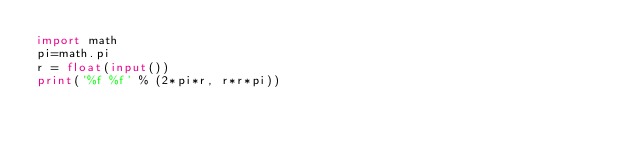<code> <loc_0><loc_0><loc_500><loc_500><_Python_>import math
pi=math.pi
r = float(input())
print('%f %f' % (2*pi*r, r*r*pi))
</code> 